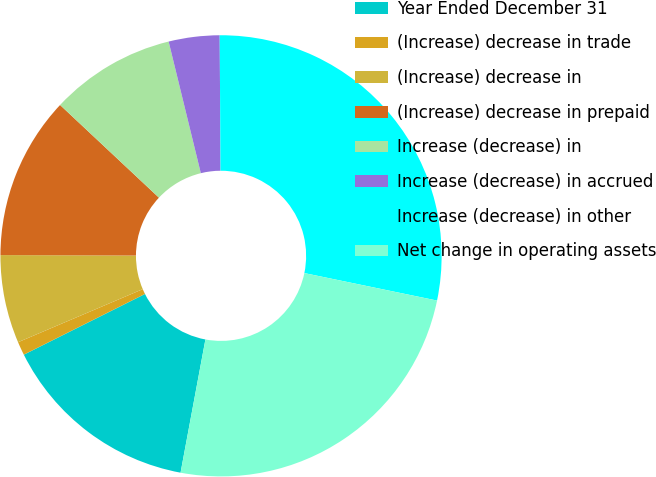Convert chart to OTSL. <chart><loc_0><loc_0><loc_500><loc_500><pie_chart><fcel>Year Ended December 31<fcel>(Increase) decrease in trade<fcel>(Increase) decrease in<fcel>(Increase) decrease in prepaid<fcel>Increase (decrease) in<fcel>Increase (decrease) in accrued<fcel>Increase (decrease) in other<fcel>Net change in operating assets<nl><fcel>14.67%<fcel>0.99%<fcel>6.46%<fcel>11.93%<fcel>9.2%<fcel>3.72%<fcel>28.35%<fcel>24.69%<nl></chart> 